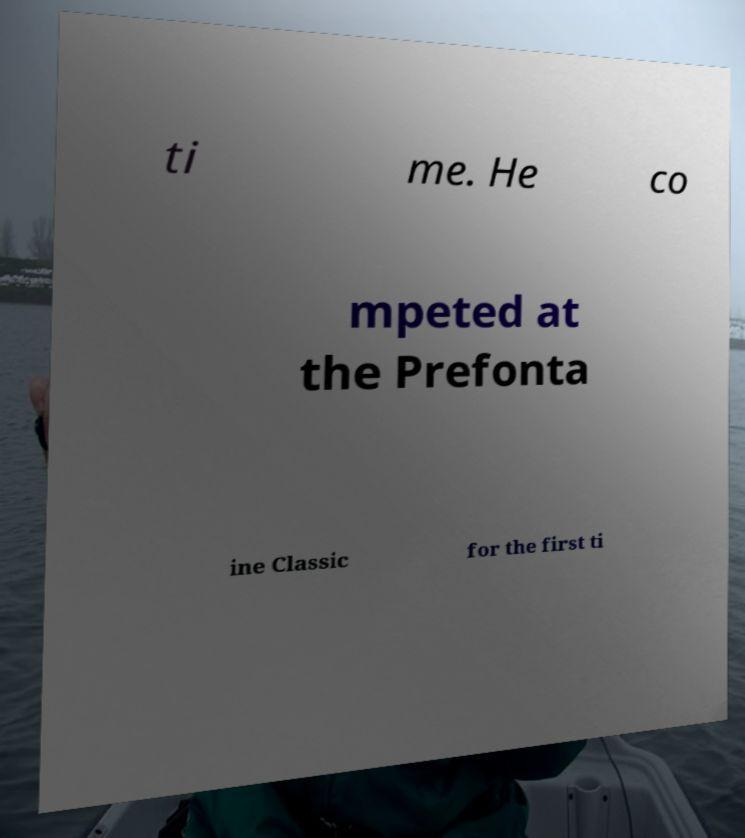Can you accurately transcribe the text from the provided image for me? ti me. He co mpeted at the Prefonta ine Classic for the first ti 